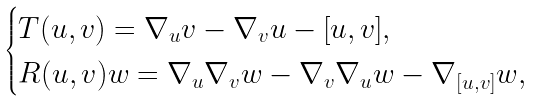Convert formula to latex. <formula><loc_0><loc_0><loc_500><loc_500>\begin{cases} T ( u , v ) = \nabla _ { u } v - \nabla _ { v } u - [ u , v ] , \\ R ( u , v ) w = \nabla _ { u } \nabla _ { v } w - \nabla _ { v } \nabla _ { u } w - \nabla _ { [ u , v ] } w , \end{cases}</formula> 